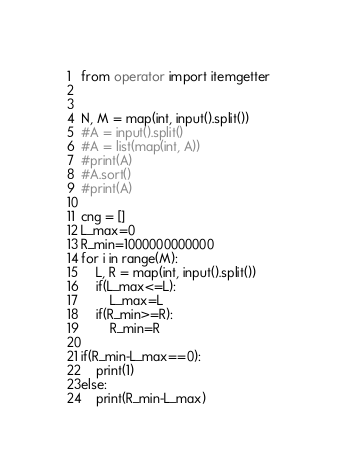Convert code to text. <code><loc_0><loc_0><loc_500><loc_500><_Python_>from operator import itemgetter
              

N, M = map(int, input().split())
#A = input().split()
#A = list(map(int, A))
#print(A)
#A.sort()
#print(A)

cng = []
L_max=0
R_min=1000000000000
for i in range(M):
    L, R = map(int, input().split())
    if(L_max<=L):
        L_max=L
    if(R_min>=R):
        R_min=R
        
if(R_min-L_max==0):
    print(1)
else:
    print(R_min-L_max)</code> 